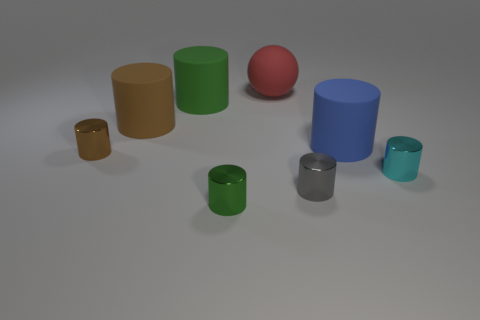There is a rubber cylinder to the right of the green shiny cylinder; how big is it?
Ensure brevity in your answer.  Large. There is a brown matte cylinder that is to the left of the tiny gray shiny object; how many cyan metallic cylinders are behind it?
Your answer should be very brief. 0. How many other cylinders are the same material as the small gray cylinder?
Offer a terse response. 3. There is a blue cylinder; are there any blue matte things in front of it?
Keep it short and to the point. No. What is the color of the ball that is the same size as the green rubber cylinder?
Offer a terse response. Red. How many things are either big objects that are in front of the red thing or big yellow cylinders?
Keep it short and to the point. 3. There is a cylinder that is both on the right side of the gray metal cylinder and behind the small cyan shiny object; how big is it?
Make the answer very short. Large. What number of other objects are the same size as the red matte thing?
Give a very brief answer. 3. There is a small object that is right of the big rubber cylinder on the right side of the cylinder in front of the gray shiny object; what color is it?
Offer a terse response. Cyan. The object that is left of the big green matte cylinder and in front of the big brown thing has what shape?
Keep it short and to the point. Cylinder. 